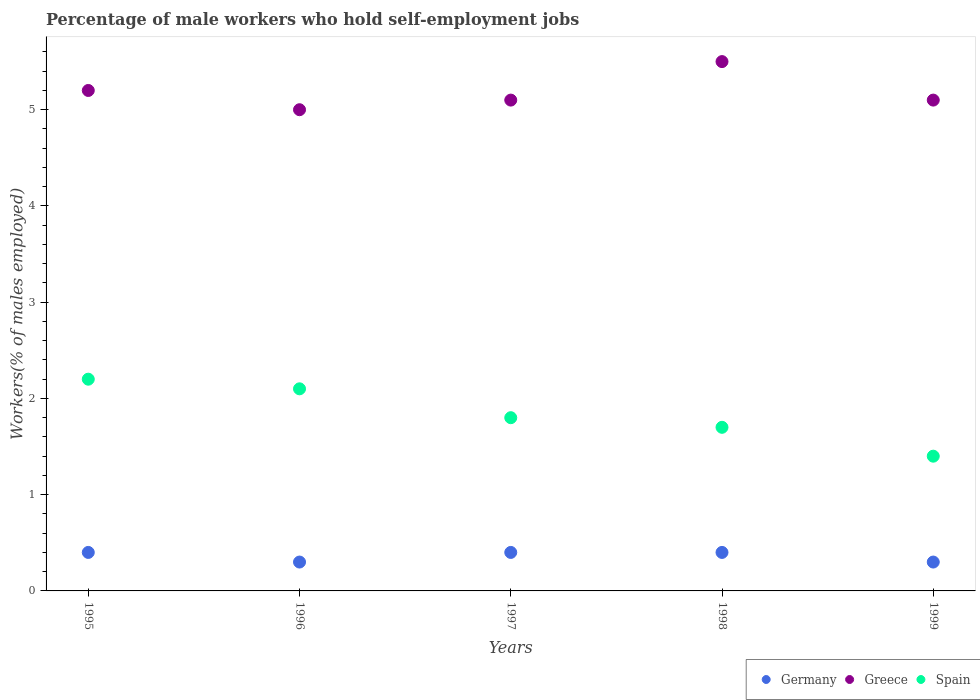How many different coloured dotlines are there?
Your response must be concise. 3. Is the number of dotlines equal to the number of legend labels?
Your answer should be compact. Yes. What is the percentage of self-employed male workers in Germany in 1998?
Your answer should be very brief. 0.4. Across all years, what is the maximum percentage of self-employed male workers in Spain?
Provide a succinct answer. 2.2. Across all years, what is the minimum percentage of self-employed male workers in Spain?
Your answer should be compact. 1.4. In which year was the percentage of self-employed male workers in Spain maximum?
Make the answer very short. 1995. In which year was the percentage of self-employed male workers in Germany minimum?
Ensure brevity in your answer.  1996. What is the total percentage of self-employed male workers in Germany in the graph?
Provide a succinct answer. 1.8. What is the difference between the percentage of self-employed male workers in Greece in 1996 and that in 1997?
Provide a succinct answer. -0.1. What is the difference between the percentage of self-employed male workers in Spain in 1998 and the percentage of self-employed male workers in Germany in 1996?
Your answer should be very brief. 1.4. What is the average percentage of self-employed male workers in Germany per year?
Offer a terse response. 0.36. In the year 1996, what is the difference between the percentage of self-employed male workers in Spain and percentage of self-employed male workers in Greece?
Offer a very short reply. -2.9. In how many years, is the percentage of self-employed male workers in Greece greater than 4.8 %?
Offer a terse response. 5. What is the ratio of the percentage of self-employed male workers in Spain in 1995 to that in 1998?
Your answer should be compact. 1.29. Is the percentage of self-employed male workers in Germany in 1996 less than that in 1998?
Ensure brevity in your answer.  Yes. What is the difference between the highest and the second highest percentage of self-employed male workers in Greece?
Your answer should be very brief. 0.3. Is the sum of the percentage of self-employed male workers in Greece in 1996 and 1998 greater than the maximum percentage of self-employed male workers in Germany across all years?
Your answer should be very brief. Yes. Is the percentage of self-employed male workers in Spain strictly greater than the percentage of self-employed male workers in Greece over the years?
Provide a short and direct response. No. Is the percentage of self-employed male workers in Greece strictly less than the percentage of self-employed male workers in Spain over the years?
Offer a very short reply. No. How many dotlines are there?
Your answer should be very brief. 3. What is the difference between two consecutive major ticks on the Y-axis?
Offer a terse response. 1. Are the values on the major ticks of Y-axis written in scientific E-notation?
Offer a terse response. No. Does the graph contain any zero values?
Offer a terse response. No. How many legend labels are there?
Give a very brief answer. 3. How are the legend labels stacked?
Your answer should be compact. Horizontal. What is the title of the graph?
Provide a short and direct response. Percentage of male workers who hold self-employment jobs. What is the label or title of the X-axis?
Keep it short and to the point. Years. What is the label or title of the Y-axis?
Give a very brief answer. Workers(% of males employed). What is the Workers(% of males employed) in Germany in 1995?
Provide a short and direct response. 0.4. What is the Workers(% of males employed) in Greece in 1995?
Your response must be concise. 5.2. What is the Workers(% of males employed) of Spain in 1995?
Ensure brevity in your answer.  2.2. What is the Workers(% of males employed) of Germany in 1996?
Your response must be concise. 0.3. What is the Workers(% of males employed) of Spain in 1996?
Make the answer very short. 2.1. What is the Workers(% of males employed) of Germany in 1997?
Your answer should be very brief. 0.4. What is the Workers(% of males employed) in Greece in 1997?
Offer a terse response. 5.1. What is the Workers(% of males employed) in Spain in 1997?
Your answer should be compact. 1.8. What is the Workers(% of males employed) in Germany in 1998?
Make the answer very short. 0.4. What is the Workers(% of males employed) of Spain in 1998?
Ensure brevity in your answer.  1.7. What is the Workers(% of males employed) of Germany in 1999?
Offer a terse response. 0.3. What is the Workers(% of males employed) in Greece in 1999?
Provide a succinct answer. 5.1. What is the Workers(% of males employed) in Spain in 1999?
Your answer should be very brief. 1.4. Across all years, what is the maximum Workers(% of males employed) of Germany?
Ensure brevity in your answer.  0.4. Across all years, what is the maximum Workers(% of males employed) in Greece?
Offer a terse response. 5.5. Across all years, what is the maximum Workers(% of males employed) in Spain?
Provide a short and direct response. 2.2. Across all years, what is the minimum Workers(% of males employed) of Germany?
Your answer should be compact. 0.3. Across all years, what is the minimum Workers(% of males employed) in Greece?
Offer a terse response. 5. Across all years, what is the minimum Workers(% of males employed) in Spain?
Make the answer very short. 1.4. What is the total Workers(% of males employed) in Germany in the graph?
Provide a short and direct response. 1.8. What is the total Workers(% of males employed) of Greece in the graph?
Offer a terse response. 25.9. What is the difference between the Workers(% of males employed) in Germany in 1995 and that in 1996?
Give a very brief answer. 0.1. What is the difference between the Workers(% of males employed) in Spain in 1995 and that in 1996?
Provide a short and direct response. 0.1. What is the difference between the Workers(% of males employed) in Germany in 1995 and that in 1997?
Provide a short and direct response. 0. What is the difference between the Workers(% of males employed) of Germany in 1995 and that in 1998?
Your answer should be very brief. 0. What is the difference between the Workers(% of males employed) of Greece in 1995 and that in 1998?
Keep it short and to the point. -0.3. What is the difference between the Workers(% of males employed) in Germany in 1995 and that in 1999?
Your answer should be very brief. 0.1. What is the difference between the Workers(% of males employed) in Greece in 1995 and that in 1999?
Offer a terse response. 0.1. What is the difference between the Workers(% of males employed) of Greece in 1996 and that in 1997?
Offer a very short reply. -0.1. What is the difference between the Workers(% of males employed) in Germany in 1996 and that in 1998?
Keep it short and to the point. -0.1. What is the difference between the Workers(% of males employed) in Greece in 1996 and that in 1998?
Keep it short and to the point. -0.5. What is the difference between the Workers(% of males employed) in Spain in 1996 and that in 1998?
Provide a short and direct response. 0.4. What is the difference between the Workers(% of males employed) of Germany in 1996 and that in 1999?
Provide a short and direct response. 0. What is the difference between the Workers(% of males employed) of Greece in 1996 and that in 1999?
Your response must be concise. -0.1. What is the difference between the Workers(% of males employed) in Greece in 1997 and that in 1998?
Your answer should be very brief. -0.4. What is the difference between the Workers(% of males employed) in Spain in 1997 and that in 1998?
Make the answer very short. 0.1. What is the difference between the Workers(% of males employed) in Germany in 1997 and that in 1999?
Provide a succinct answer. 0.1. What is the difference between the Workers(% of males employed) of Spain in 1997 and that in 1999?
Your answer should be very brief. 0.4. What is the difference between the Workers(% of males employed) of Germany in 1998 and that in 1999?
Your answer should be compact. 0.1. What is the difference between the Workers(% of males employed) in Germany in 1995 and the Workers(% of males employed) in Spain in 1996?
Provide a short and direct response. -1.7. What is the difference between the Workers(% of males employed) of Germany in 1995 and the Workers(% of males employed) of Spain in 1997?
Your answer should be very brief. -1.4. What is the difference between the Workers(% of males employed) of Germany in 1995 and the Workers(% of males employed) of Spain in 1998?
Your answer should be very brief. -1.3. What is the difference between the Workers(% of males employed) in Greece in 1995 and the Workers(% of males employed) in Spain in 1999?
Your response must be concise. 3.8. What is the difference between the Workers(% of males employed) in Germany in 1996 and the Workers(% of males employed) in Greece in 1997?
Your answer should be compact. -4.8. What is the difference between the Workers(% of males employed) of Germany in 1996 and the Workers(% of males employed) of Spain in 1997?
Offer a very short reply. -1.5. What is the difference between the Workers(% of males employed) in Greece in 1996 and the Workers(% of males employed) in Spain in 1997?
Your answer should be compact. 3.2. What is the difference between the Workers(% of males employed) of Germany in 1996 and the Workers(% of males employed) of Greece in 1998?
Your response must be concise. -5.2. What is the difference between the Workers(% of males employed) of Germany in 1996 and the Workers(% of males employed) of Spain in 1998?
Offer a terse response. -1.4. What is the difference between the Workers(% of males employed) in Greece in 1996 and the Workers(% of males employed) in Spain in 1999?
Provide a short and direct response. 3.6. What is the difference between the Workers(% of males employed) in Germany in 1997 and the Workers(% of males employed) in Spain in 1998?
Offer a terse response. -1.3. What is the difference between the Workers(% of males employed) in Greece in 1997 and the Workers(% of males employed) in Spain in 1998?
Provide a short and direct response. 3.4. What is the difference between the Workers(% of males employed) in Germany in 1997 and the Workers(% of males employed) in Greece in 1999?
Keep it short and to the point. -4.7. What is the difference between the Workers(% of males employed) in Germany in 1998 and the Workers(% of males employed) in Spain in 1999?
Offer a very short reply. -1. What is the difference between the Workers(% of males employed) of Greece in 1998 and the Workers(% of males employed) of Spain in 1999?
Your answer should be very brief. 4.1. What is the average Workers(% of males employed) in Germany per year?
Offer a very short reply. 0.36. What is the average Workers(% of males employed) of Greece per year?
Keep it short and to the point. 5.18. What is the average Workers(% of males employed) in Spain per year?
Offer a very short reply. 1.84. In the year 1995, what is the difference between the Workers(% of males employed) of Germany and Workers(% of males employed) of Greece?
Give a very brief answer. -4.8. In the year 1995, what is the difference between the Workers(% of males employed) in Greece and Workers(% of males employed) in Spain?
Provide a short and direct response. 3. In the year 1996, what is the difference between the Workers(% of males employed) of Germany and Workers(% of males employed) of Greece?
Provide a succinct answer. -4.7. In the year 1996, what is the difference between the Workers(% of males employed) of Germany and Workers(% of males employed) of Spain?
Make the answer very short. -1.8. In the year 1996, what is the difference between the Workers(% of males employed) in Greece and Workers(% of males employed) in Spain?
Offer a very short reply. 2.9. In the year 1997, what is the difference between the Workers(% of males employed) in Germany and Workers(% of males employed) in Greece?
Give a very brief answer. -4.7. In the year 1997, what is the difference between the Workers(% of males employed) in Germany and Workers(% of males employed) in Spain?
Provide a short and direct response. -1.4. In the year 1998, what is the difference between the Workers(% of males employed) in Germany and Workers(% of males employed) in Greece?
Keep it short and to the point. -5.1. In the year 1998, what is the difference between the Workers(% of males employed) of Germany and Workers(% of males employed) of Spain?
Your response must be concise. -1.3. In the year 1999, what is the difference between the Workers(% of males employed) of Germany and Workers(% of males employed) of Greece?
Keep it short and to the point. -4.8. In the year 1999, what is the difference between the Workers(% of males employed) in Greece and Workers(% of males employed) in Spain?
Your answer should be very brief. 3.7. What is the ratio of the Workers(% of males employed) of Germany in 1995 to that in 1996?
Provide a short and direct response. 1.33. What is the ratio of the Workers(% of males employed) of Greece in 1995 to that in 1996?
Provide a succinct answer. 1.04. What is the ratio of the Workers(% of males employed) in Spain in 1995 to that in 1996?
Offer a very short reply. 1.05. What is the ratio of the Workers(% of males employed) in Greece in 1995 to that in 1997?
Provide a succinct answer. 1.02. What is the ratio of the Workers(% of males employed) in Spain in 1995 to that in 1997?
Give a very brief answer. 1.22. What is the ratio of the Workers(% of males employed) of Greece in 1995 to that in 1998?
Offer a very short reply. 0.95. What is the ratio of the Workers(% of males employed) of Spain in 1995 to that in 1998?
Give a very brief answer. 1.29. What is the ratio of the Workers(% of males employed) in Germany in 1995 to that in 1999?
Provide a succinct answer. 1.33. What is the ratio of the Workers(% of males employed) of Greece in 1995 to that in 1999?
Offer a very short reply. 1.02. What is the ratio of the Workers(% of males employed) of Spain in 1995 to that in 1999?
Give a very brief answer. 1.57. What is the ratio of the Workers(% of males employed) of Germany in 1996 to that in 1997?
Provide a succinct answer. 0.75. What is the ratio of the Workers(% of males employed) of Greece in 1996 to that in 1997?
Provide a short and direct response. 0.98. What is the ratio of the Workers(% of males employed) of Greece in 1996 to that in 1998?
Offer a very short reply. 0.91. What is the ratio of the Workers(% of males employed) in Spain in 1996 to that in 1998?
Your response must be concise. 1.24. What is the ratio of the Workers(% of males employed) in Germany in 1996 to that in 1999?
Your answer should be very brief. 1. What is the ratio of the Workers(% of males employed) of Greece in 1996 to that in 1999?
Provide a succinct answer. 0.98. What is the ratio of the Workers(% of males employed) of Germany in 1997 to that in 1998?
Provide a succinct answer. 1. What is the ratio of the Workers(% of males employed) in Greece in 1997 to that in 1998?
Offer a very short reply. 0.93. What is the ratio of the Workers(% of males employed) in Spain in 1997 to that in 1998?
Offer a very short reply. 1.06. What is the ratio of the Workers(% of males employed) of Greece in 1997 to that in 1999?
Give a very brief answer. 1. What is the ratio of the Workers(% of males employed) in Spain in 1997 to that in 1999?
Your answer should be very brief. 1.29. What is the ratio of the Workers(% of males employed) in Greece in 1998 to that in 1999?
Your answer should be very brief. 1.08. What is the ratio of the Workers(% of males employed) in Spain in 1998 to that in 1999?
Give a very brief answer. 1.21. What is the difference between the highest and the second highest Workers(% of males employed) of Germany?
Ensure brevity in your answer.  0. What is the difference between the highest and the second highest Workers(% of males employed) of Spain?
Offer a very short reply. 0.1. 